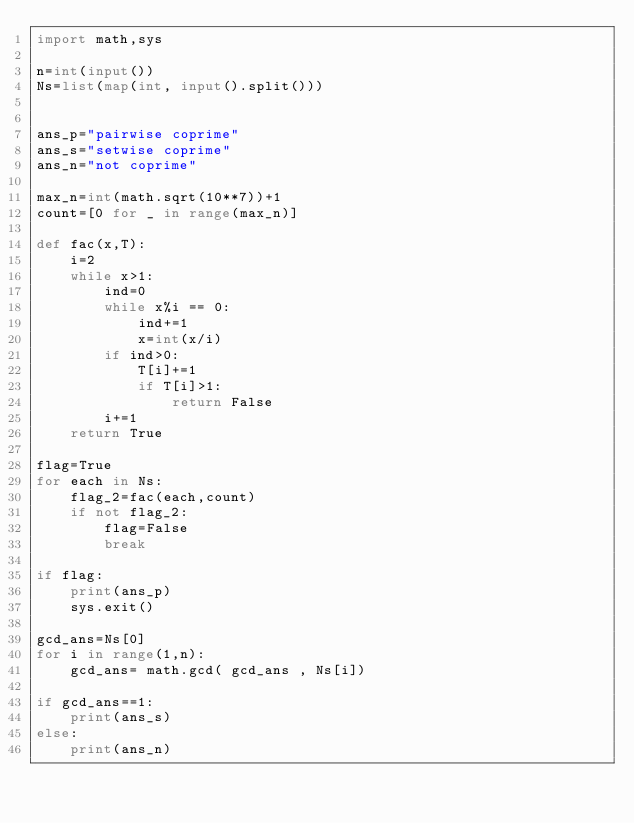Convert code to text. <code><loc_0><loc_0><loc_500><loc_500><_Python_>import math,sys

n=int(input())
Ns=list(map(int, input().split()))


ans_p="pairwise coprime"
ans_s="setwise coprime"
ans_n="not coprime"

max_n=int(math.sqrt(10**7))+1
count=[0 for _ in range(max_n)]

def fac(x,T):
    i=2
    while x>1:
        ind=0
        while x%i == 0:
            ind+=1
            x=int(x/i)
        if ind>0:
            T[i]+=1
            if T[i]>1:
                return False
        i+=1
    return True

flag=True
for each in Ns:
    flag_2=fac(each,count)
    if not flag_2:
        flag=False
        break

if flag:
    print(ans_p)
    sys.exit()

gcd_ans=Ns[0]
for i in range(1,n):
    gcd_ans= math.gcd( gcd_ans , Ns[i])

if gcd_ans==1:
    print(ans_s)
else:
    print(ans_n)</code> 